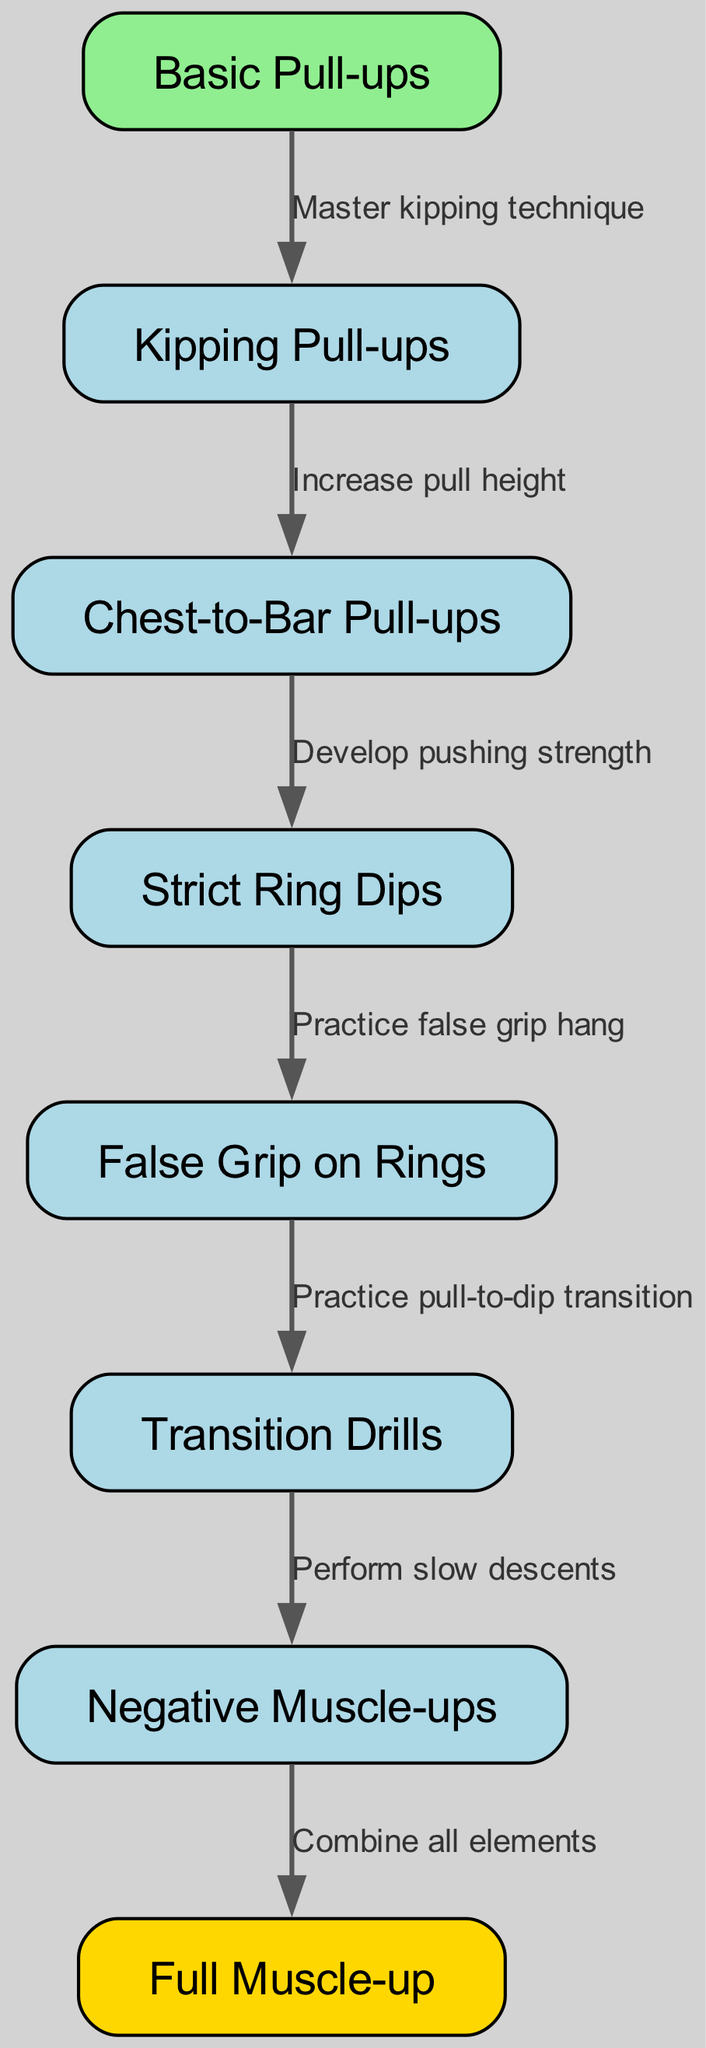What is the starting exercise in the progression? The starting exercise is indicated as the first node in the diagram, which is labeled "Basic Pull-ups."
Answer: Basic Pull-ups How many exercises are listed in the progression? Counting all nodes in the diagram, there are a total of eight exercises presented in the progression.
Answer: 8 What is the last exercise in the progression? The last exercise is shown as the final node, which is labeled "Full Muscle-up."
Answer: Full Muscle-up What follows after "Strict Ring Dips"? According to the edges of the diagram, "False Grip on Rings" follows after "Strict Ring Dips."
Answer: False Grip on Rings What is required to move from "Kipping Pull-ups" to "Chest-to-Bar Pull-ups"? The edge label between these two nodes states that one must "Increase pull height" to progress from "Kipping Pull-ups" to "Chest-to-Bar Pull-ups."
Answer: Increase pull height What must be practiced before moving on to "Transition Drills"? The flow between "False Grip on Rings" and "Transition Drills" indicates that one must "Practice pull-to-dip transition" before proceeding to "Transition Drills."
Answer: Practice pull-to-dip transition What is the significance of the "Negative Muscle-ups" step? "Negative Muscle-ups" serves as a crucial step that involves the process of "Perform slow descents," which helps to combine elements from previous exercises in the muscle-up progression.
Answer: Perform slow descents Which two exercises are directly connected and require "Develop pushing strength"? The edge label indicates that "Chest-to-Bar Pull-ups" is directly connected to "Strict Ring Dips," where one must "Develop pushing strength."
Answer: Chest-to-Bar Pull-ups and Strict Ring Dips 